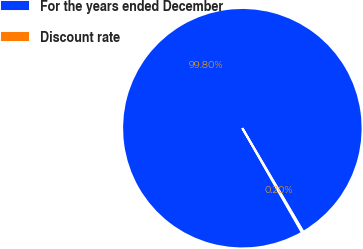Convert chart. <chart><loc_0><loc_0><loc_500><loc_500><pie_chart><fcel>For the years ended December<fcel>Discount rate<nl><fcel>99.8%<fcel>0.2%<nl></chart> 